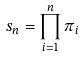Convert formula to latex. <formula><loc_0><loc_0><loc_500><loc_500>s _ { n } = \prod _ { i = 1 } ^ { n } \pi _ { i }</formula> 